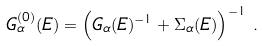Convert formula to latex. <formula><loc_0><loc_0><loc_500><loc_500>G _ { \alpha } ^ { ( 0 ) } ( E ) = \left ( G _ { \alpha } ( E ) ^ { - 1 } + \Sigma _ { \alpha } ( E ) \right ) ^ { - 1 } \, .</formula> 